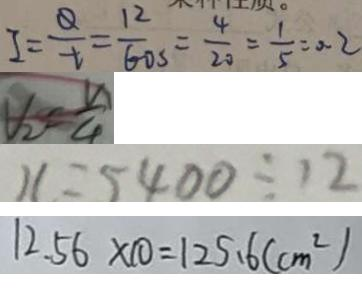Convert formula to latex. <formula><loc_0><loc_0><loc_500><loc_500>I = \frac { Q } { t } = \frac { 1 2 } { 6 0 s } = \frac { 4 } { 2 0 } = \frac { 1 } { 5 } = 0 . 2 
 V _ { 2 } = \frac { v } { 4 } 
 x = 5 4 0 0 \div 1 2 
 1 2 . 5 6 \times 1 0 = 1 2 5 . 6 ( c m ^ { 2 } )</formula> 